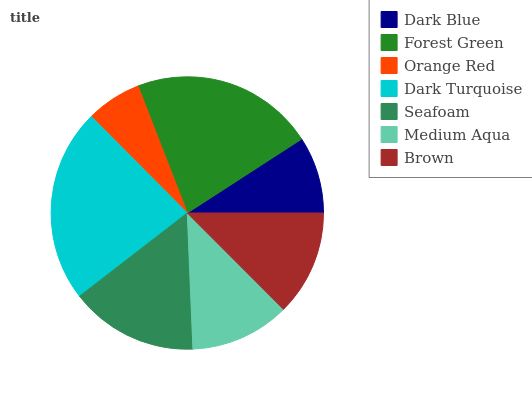Is Orange Red the minimum?
Answer yes or no. Yes. Is Dark Turquoise the maximum?
Answer yes or no. Yes. Is Forest Green the minimum?
Answer yes or no. No. Is Forest Green the maximum?
Answer yes or no. No. Is Forest Green greater than Dark Blue?
Answer yes or no. Yes. Is Dark Blue less than Forest Green?
Answer yes or no. Yes. Is Dark Blue greater than Forest Green?
Answer yes or no. No. Is Forest Green less than Dark Blue?
Answer yes or no. No. Is Brown the high median?
Answer yes or no. Yes. Is Brown the low median?
Answer yes or no. Yes. Is Dark Blue the high median?
Answer yes or no. No. Is Forest Green the low median?
Answer yes or no. No. 